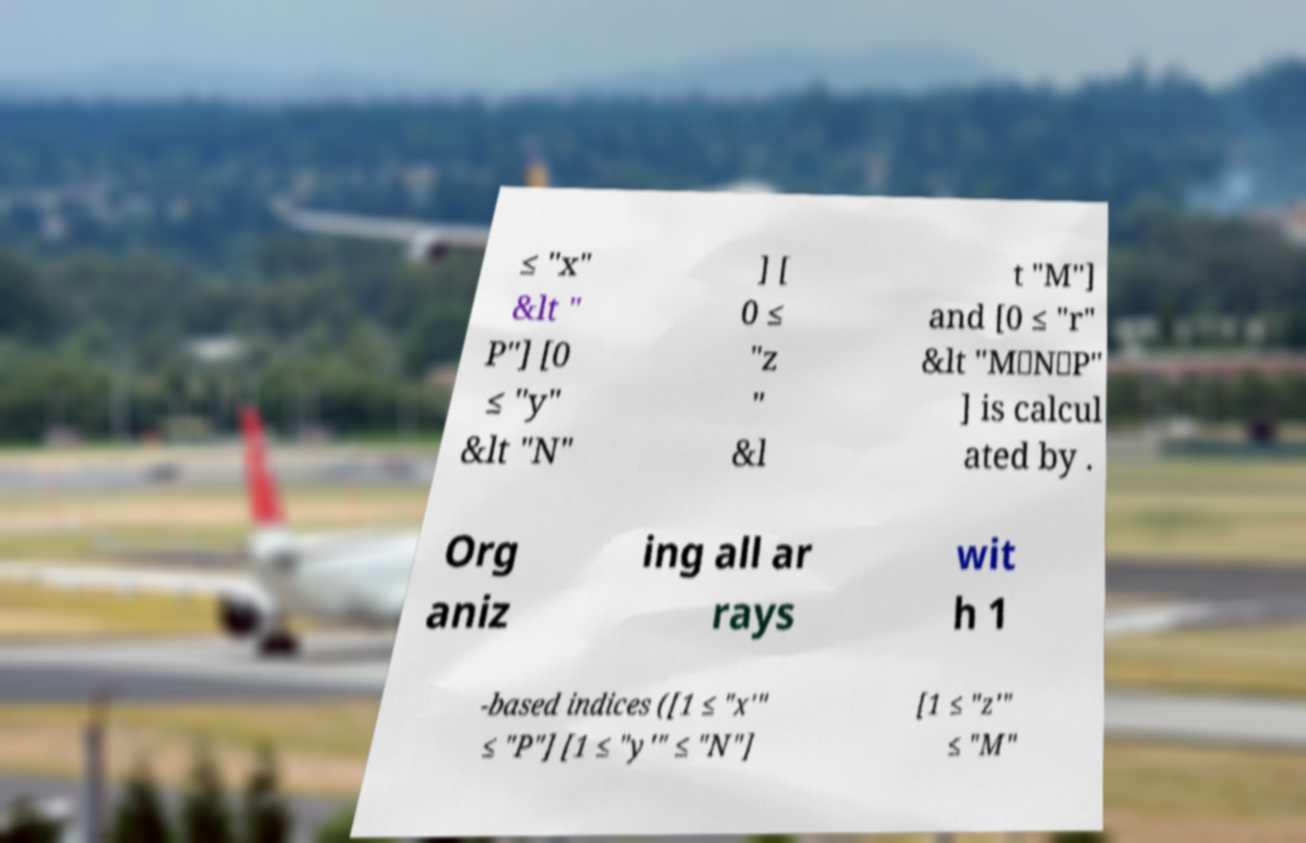Could you assist in decoding the text presented in this image and type it out clearly? ≤ "x" &lt " P"] [0 ≤ "y" &lt "N" ] [ 0 ≤ "z " &l t "M"] and [0 ≤ "r" &lt "M⋅N⋅P" ] is calcul ated by . Org aniz ing all ar rays wit h 1 -based indices ([1 ≤ "x′" ≤ "P"] [1 ≤ "y′" ≤ "N"] [1 ≤ "z′" ≤ "M" 